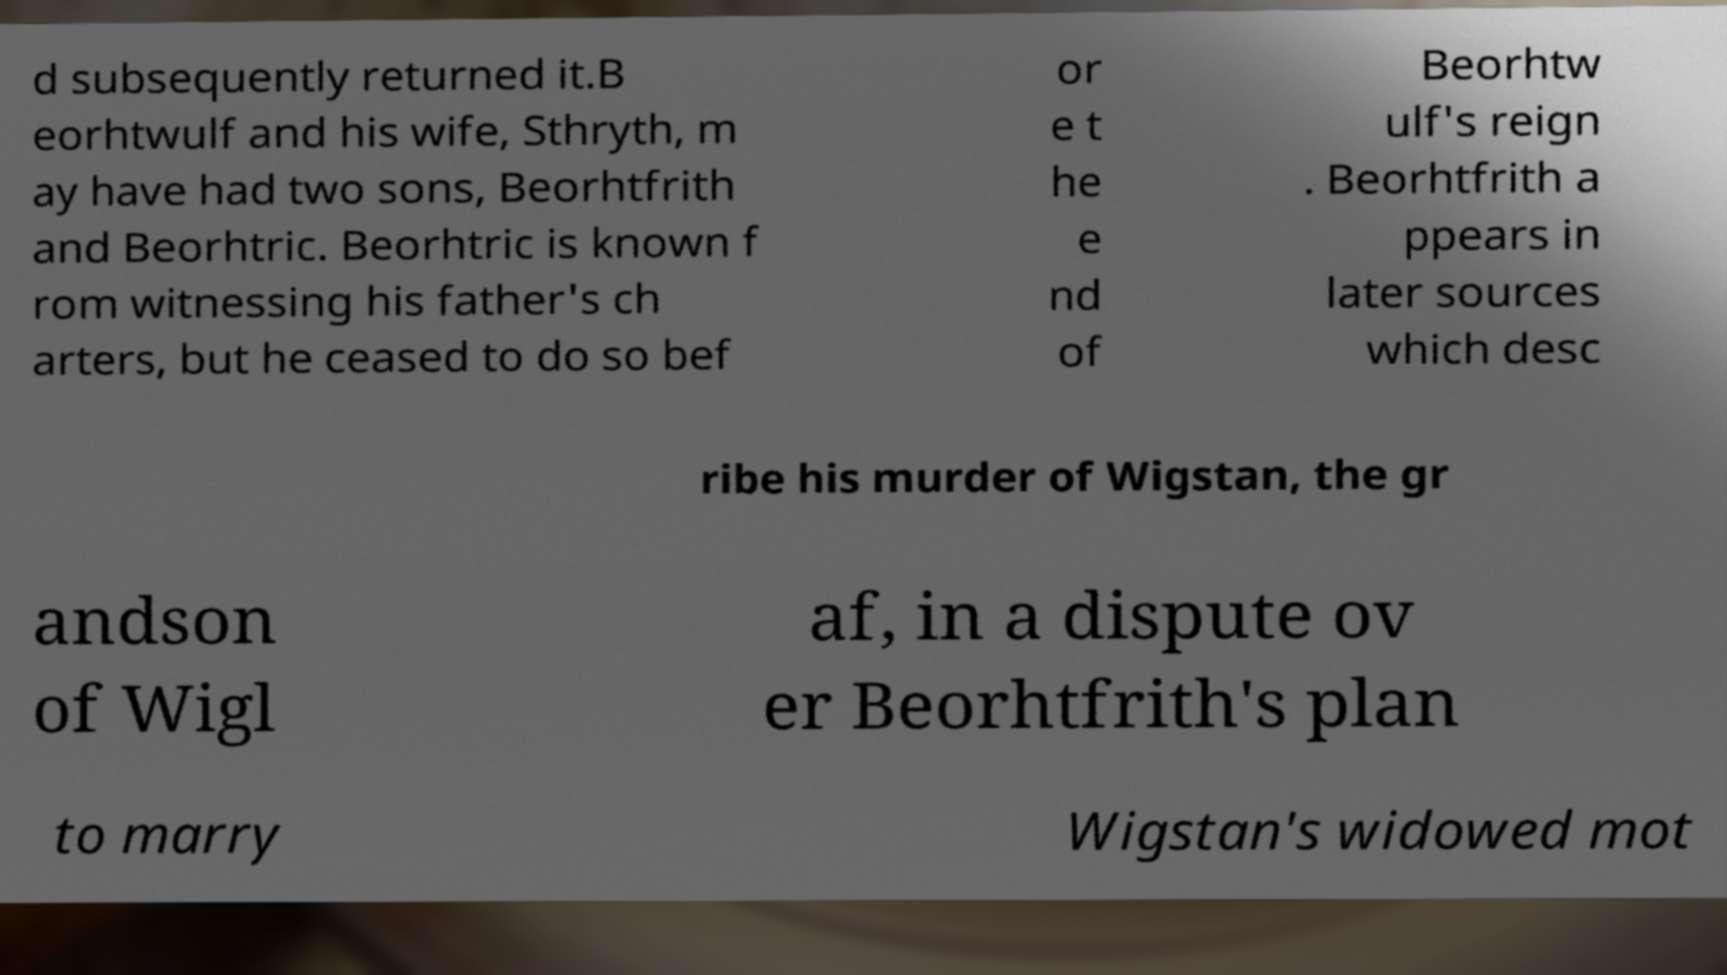What messages or text are displayed in this image? I need them in a readable, typed format. d subsequently returned it.B eorhtwulf and his wife, Sthryth, m ay have had two sons, Beorhtfrith and Beorhtric. Beorhtric is known f rom witnessing his father's ch arters, but he ceased to do so bef or e t he e nd of Beorhtw ulf's reign . Beorhtfrith a ppears in later sources which desc ribe his murder of Wigstan, the gr andson of Wigl af, in a dispute ov er Beorhtfrith's plan to marry Wigstan's widowed mot 